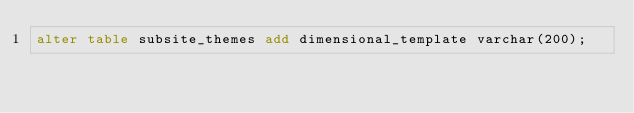Convert code to text. <code><loc_0><loc_0><loc_500><loc_500><_SQL_>alter table subsite_themes add dimensional_template varchar(200);
</code> 